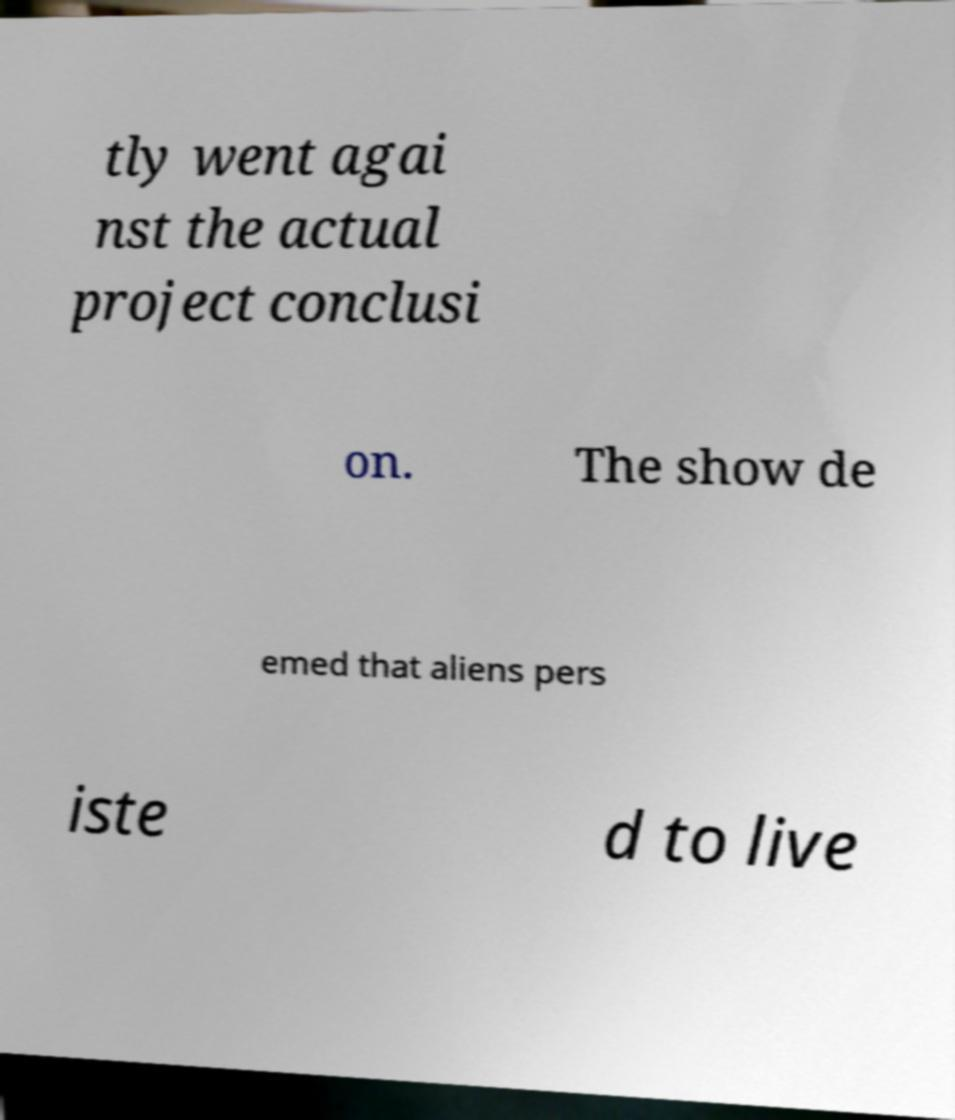Please identify and transcribe the text found in this image. tly went agai nst the actual project conclusi on. The show de emed that aliens pers iste d to live 